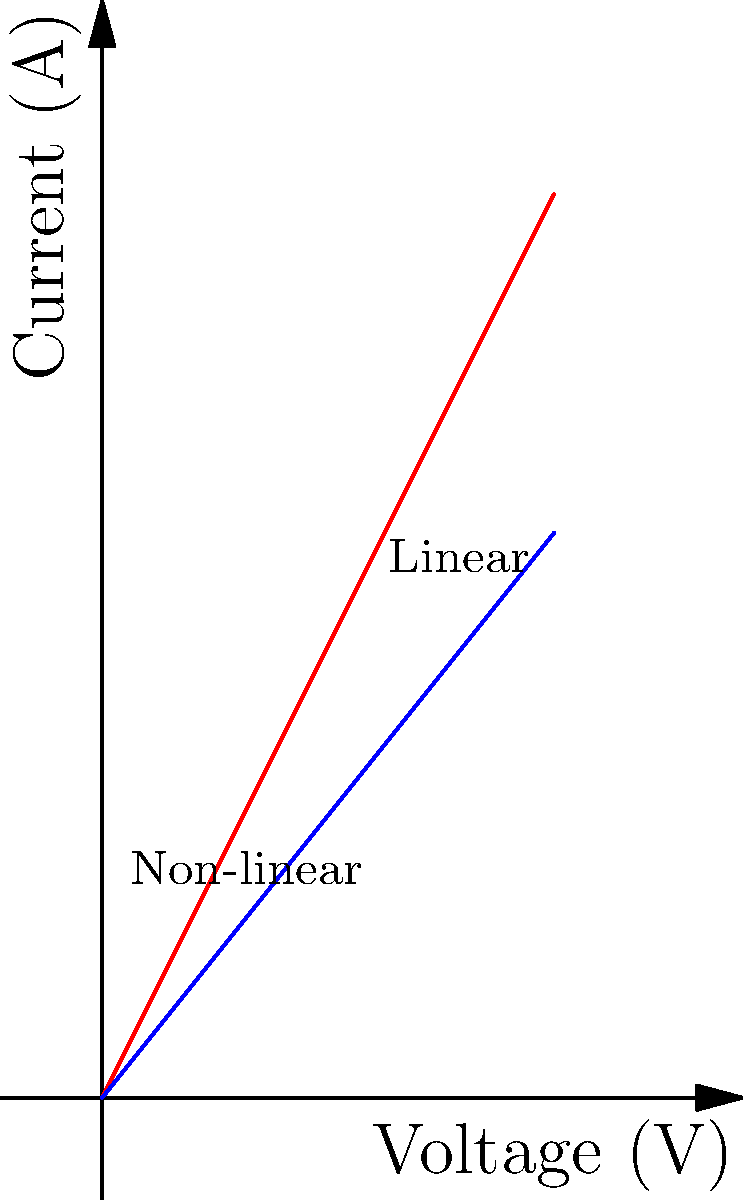In this artistic representation of voltage-current relationships, how does the color gradient symbolize the nature of the depicted electrical components, and what might this suggest about their "emotional response" to increasing voltage? To answer this question, let's analyze the image step-by-step:

1. The graph shows two curves: a straight line and a parabolic curve.

2. The straight line represents a linear relationship, likely depicting Ohm's law for a resistor: $I = V/R$.

3. The parabolic curve represents a non-linear relationship, possibly for a component like a diode or transistor.

4. The color gradient for the linear relationship transitions from blue to purple, symbolizing a steady, predictable "emotional response" to voltage changes.

5. The non-linear relationship's color gradient shifts from red to purple, suggesting a more dramatic or "passionate" response to voltage increases.

6. In electrical terms, the linear component (resistor) maintains a constant rate of current increase with voltage, while the non-linear component experiences a more rapid current increase at higher voltages.

7. Artistically, this could be interpreted as the linear component having a "calm" or "stable" personality, while the non-linear component has a more "excited" or "volatile" nature.

8. The convergence of both curves towards purple at higher voltages might symbolize a shared "intensity" or "saturation" of response at extreme conditions.

This artistic representation uses color to evoke emotional responses to electrical behaviors, bridging the gap between scientific concepts and artistic expression.
Answer: The color gradient symbolizes steady (blue-purple) vs. dramatic (red-purple) responses, suggesting calm vs. volatile "emotional" reactions to voltage increases. 